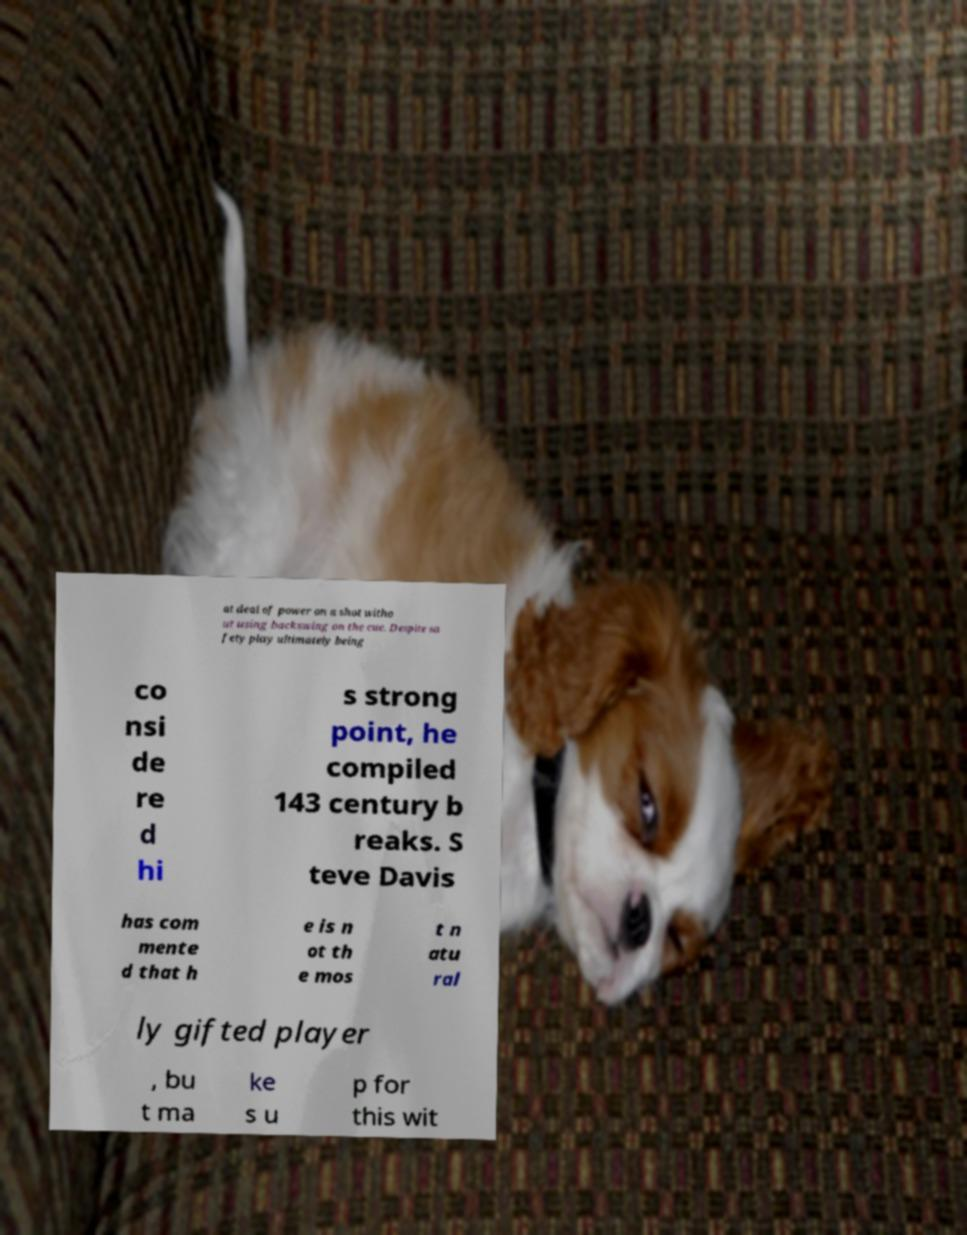Please read and relay the text visible in this image. What does it say? at deal of power on a shot witho ut using backswing on the cue. Despite sa fety play ultimately being co nsi de re d hi s strong point, he compiled 143 century b reaks. S teve Davis has com mente d that h e is n ot th e mos t n atu ral ly gifted player , bu t ma ke s u p for this wit 